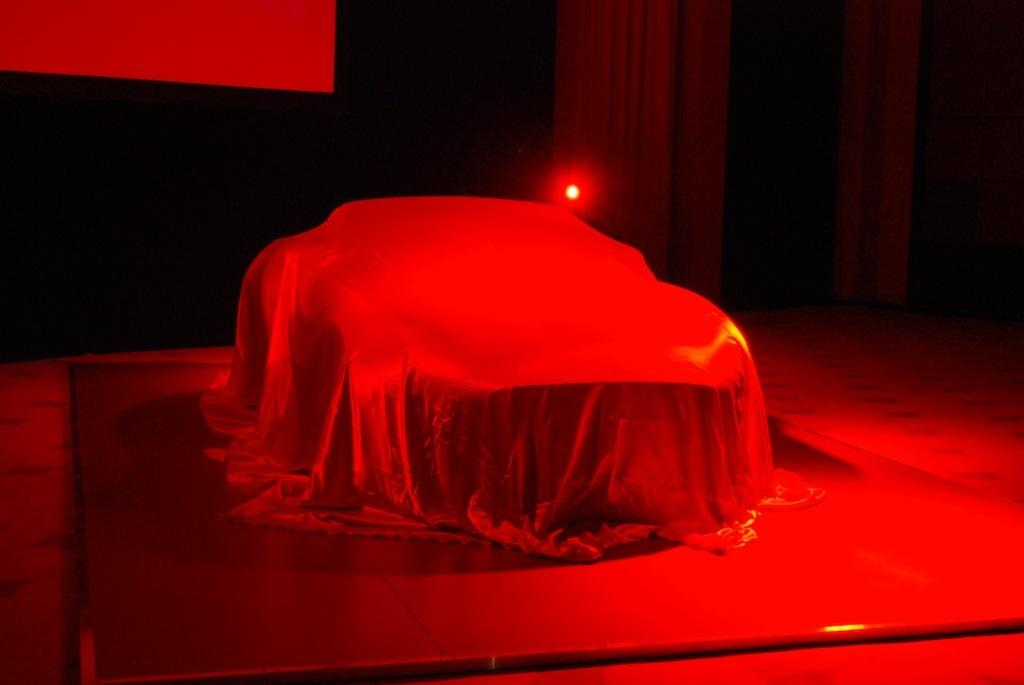What is placed on the board in the image? There is an object on a board in the image. Can you describe the surface on which the board is placed? The board is on a surface. What colors are present in the background of the image? The background has black and red colors. Is there any specific lighting visible in the image? The red color light is visible in the image. Can you tell me how many quinces are being cooked in the oven in the image? There is no oven or quinces present in the image. What type of street is visible in the background of the image? There is no street visible in the background of the image; it features black and red colors. 